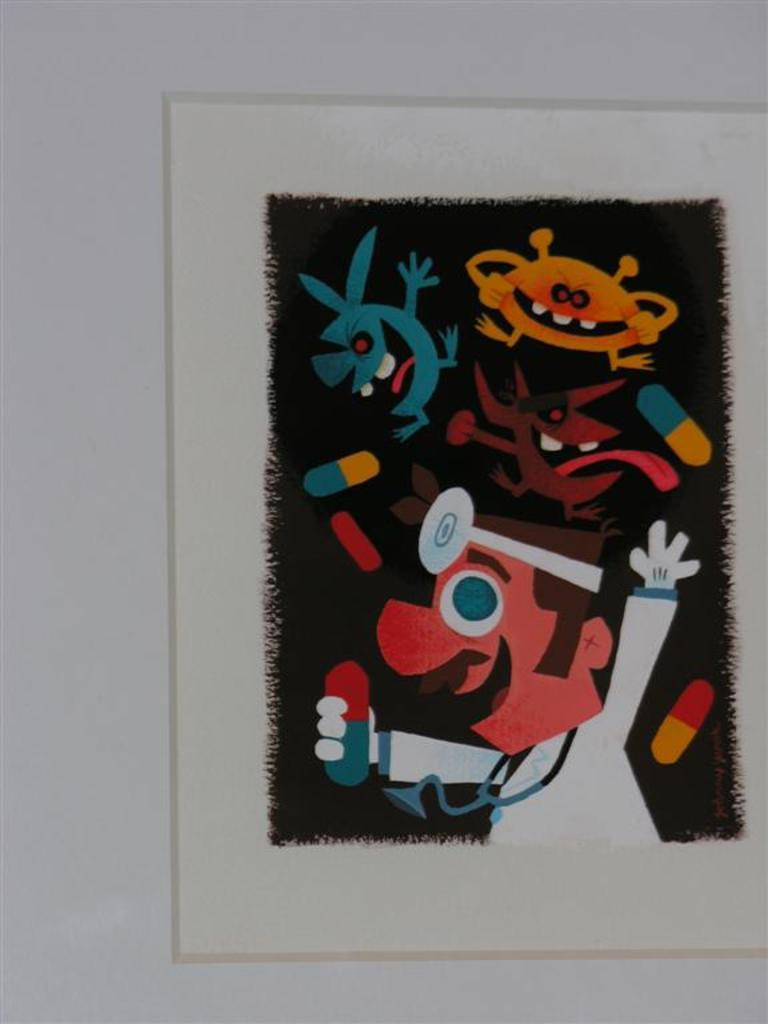What is present in the image? There is a poster in the image. What can be seen on the poster? The poster has a cartoon painting on it. What is the opinion of the lock on the cartoon painting in the image? There is no lock present in the image, and therefore no opinion can be attributed to it. 